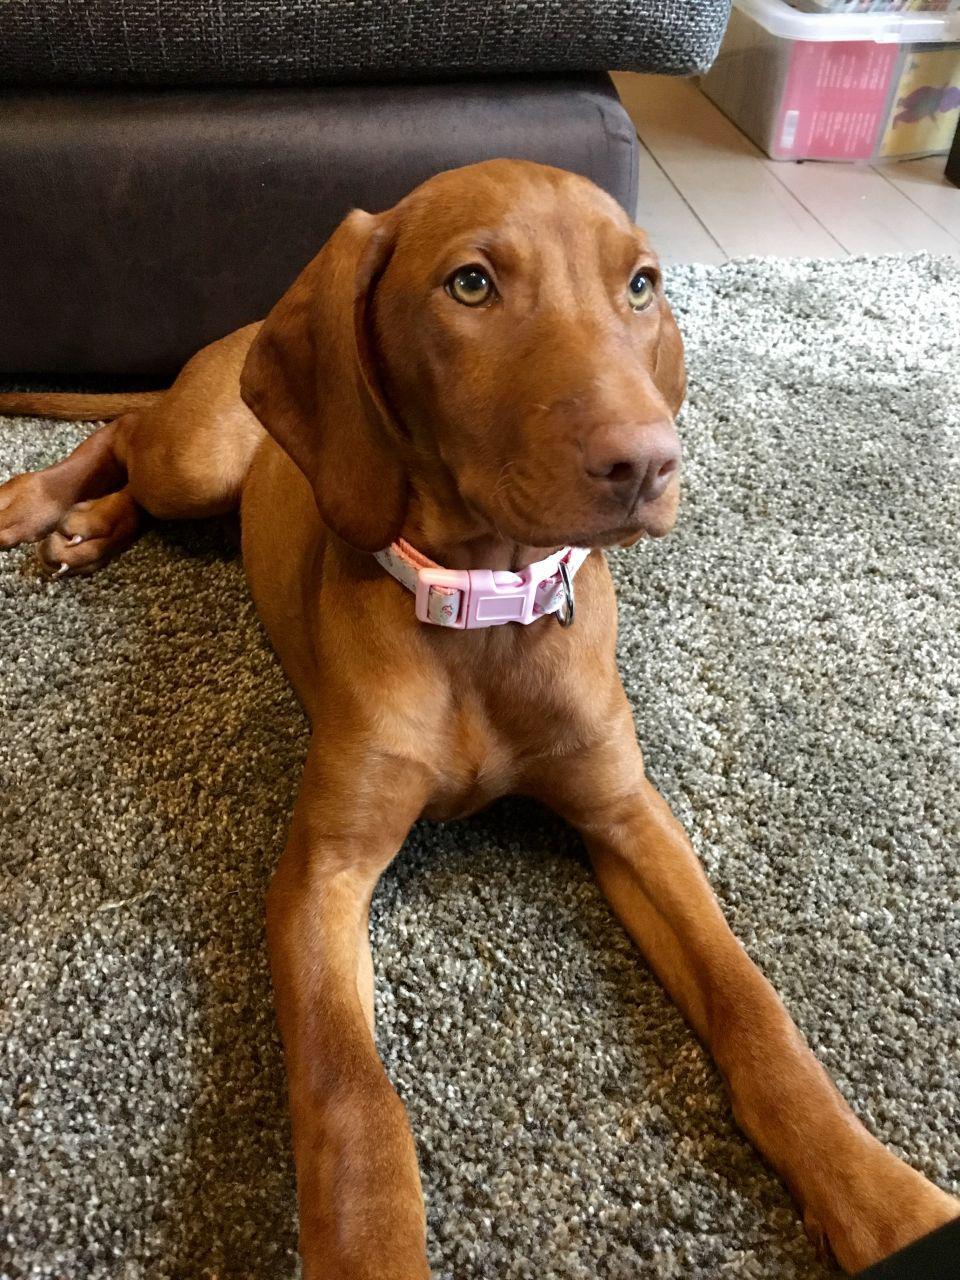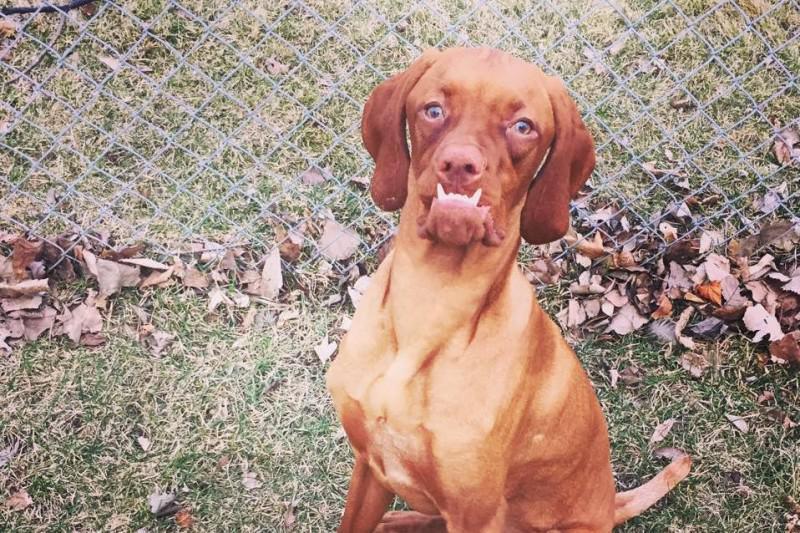The first image is the image on the left, the second image is the image on the right. Assess this claim about the two images: "One dog is standing.". Correct or not? Answer yes or no. No. 